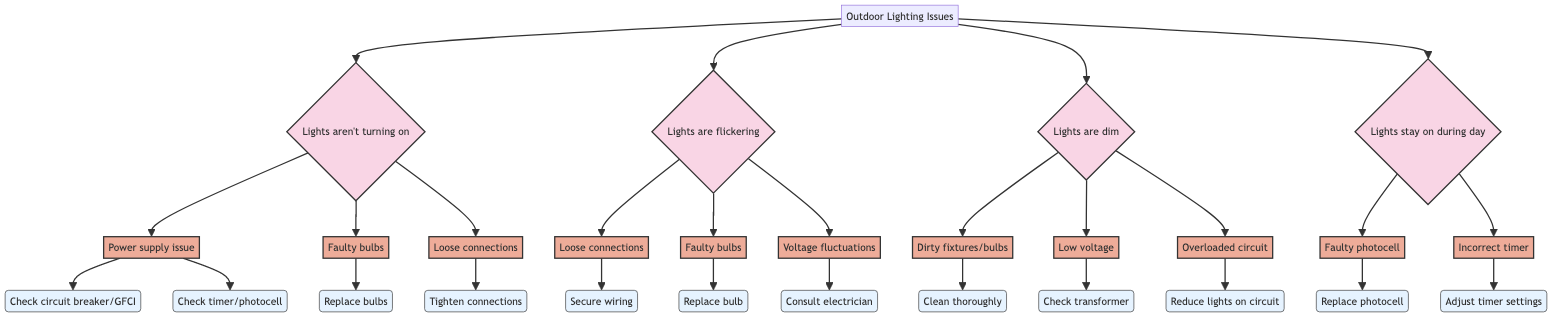What is the first symptom listed in the diagram? The first symptom node under "Outdoor Lighting Issues" is "Outdoor lights aren't turning on." This can be identified as it's the first branch extending from the main node.
Answer: Outdoor lights aren't turning on How many symptoms are identified in the diagram? There are four symptoms listed in the diagram: "Outdoor lights aren't turning on," "Outdoor lights are flickering," "Outdoor lights are dim," and "Outdoor lights stay on during the day." Counting each unique symptom provides the total.
Answer: Four What is the solution for faulty bulbs under flickering lights? For the symptom "Outdoor lights are flickering," if the cause is 'Faulty bulbs,' the solution is to "Try replacing the bulb with a new one." Trace the path from "Lights are flickering" to "Faulty bulbs" and then to the solution node.
Answer: Try replacing the bulb with a new one Which cause has the most solutions listed? The symptom "Outdoor lights aren't turning on" has three possible causes: "Power supply issue," "Faulty bulbs," and "Loose connections." The "Power supply issue" has two solutions, while "Faulty bulbs" has one solution and "Loose connections" has one solution. Therefore, "Power supply issue" has the most solutions.
Answer: Power supply issue What should you do if your outdoor lights stay on during the day due to a faulty photocell? The solution for a faulty photocell is to "Replace the photocell sensor." This conclusion is drawn from following the path related to the symptom "Outdoor lights stay on during the day" and reaching the cause "Faulty photocell," which leads to its solution.
Answer: Replace the photocell sensor What is a possible cause of dim outdoor lights? One possible cause for dim outdoor lights is "Dirty fixtures or bulbs." This directly connects from the symptom "Outdoor lights are dim" to its corresponding possible cause.
Answer: Dirty fixtures or bulbs Which symptom relates to voltage fluctuations? The symptom "Outdoor lights are flickering" is related to voltage fluctuations. This is determined by tracing possible causes stemming from the flickering symptom.
Answer: Outdoor lights are flickering How many solutions are listed for the cause of overloaded circuits? There is one solution listed for the cause "Overloaded circuit," which is to "Reduce the number of lights on the circuit." This can be found by following the appropriate path from the symptom "Outdoor lights are dim" down to the cause and its corresponding solution.
Answer: One 